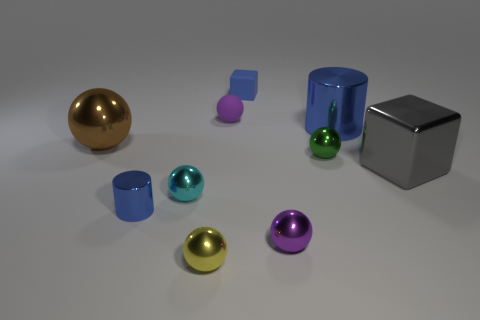Is there anything else that has the same material as the big gray cube?
Keep it short and to the point. Yes. What number of shiny things are both on the left side of the big blue cylinder and behind the tiny yellow ball?
Your answer should be compact. 5. How many things are either spheres in front of the green thing or small purple things behind the tiny blue cylinder?
Keep it short and to the point. 4. What number of other objects are the same shape as the green metallic thing?
Provide a short and direct response. 5. There is a tiny metal thing behind the large gray cube; is its color the same as the small cylinder?
Make the answer very short. No. What number of other objects are there of the same size as the brown sphere?
Give a very brief answer. 2. Are the big gray object and the brown ball made of the same material?
Keep it short and to the point. Yes. What color is the cylinder behind the shiny cylinder in front of the big gray block?
Offer a terse response. Blue. What size is the yellow thing that is the same shape as the brown object?
Your response must be concise. Small. Is the big metallic ball the same color as the large shiny block?
Your response must be concise. No. 